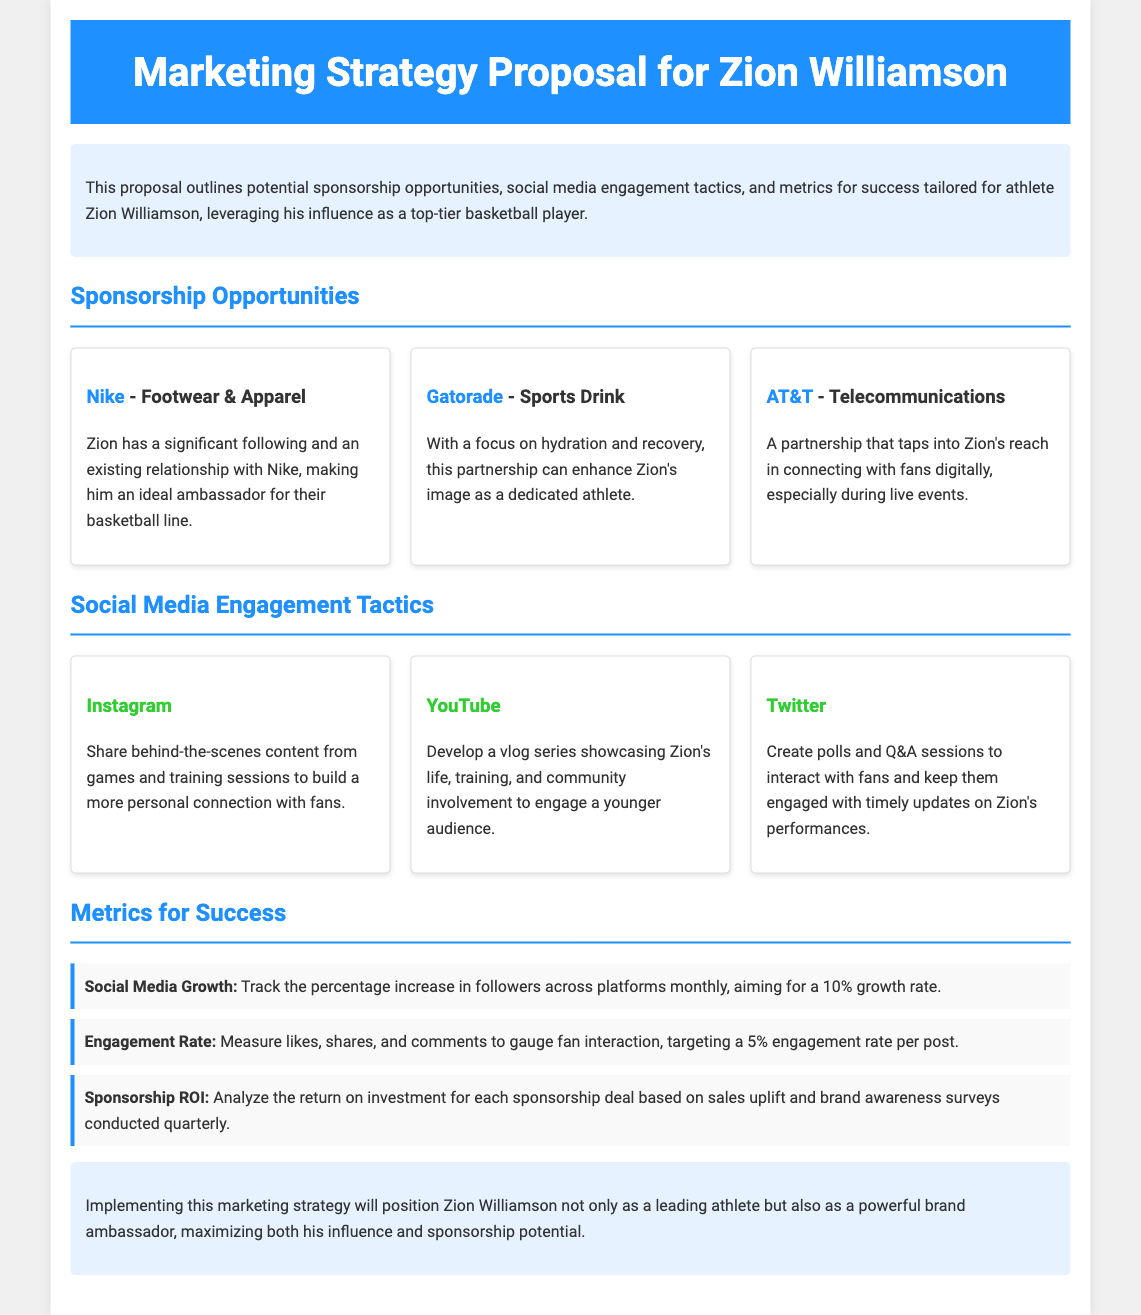what is the title of the proposal? The title is specified at the top of the document in the header section.
Answer: Marketing Strategy Proposal for Zion Williamson who is the main athlete discussed in the document? The document focuses on the marketing strategy for a specific athlete, as stated in the introduction.
Answer: Zion Williamson what brand is mentioned as a potential sponsorship for footwear and apparel? The sponsorship opportunities include several brands, one of which is highlighted for footwear.
Answer: Nike what is the targeted engagement rate per post? The document specifies a particular performance metric associated with fan interaction to aim for.
Answer: 5% which platform is suggested for sharing behind-the-scenes content? The social media engagement tactics indicate a platform chosen for a personal connection with fans.
Answer: Instagram how many sponsorship opportunities are mentioned in the document? The proposal outlines a specific number of potential sponsorships, each with focused brands.
Answer: Three what is the monthly growth rate goal for social media followers? The metrics for success specify a percentage increase goal for social media followers that should be achieved.
Answer: 10% what is the primary purpose of the marketing strategy? The conclusion summarizes the overall aim of the marketing strategy outlined in the document.
Answer: Position Zion Williamson as a leading athlete and brand ambassador 